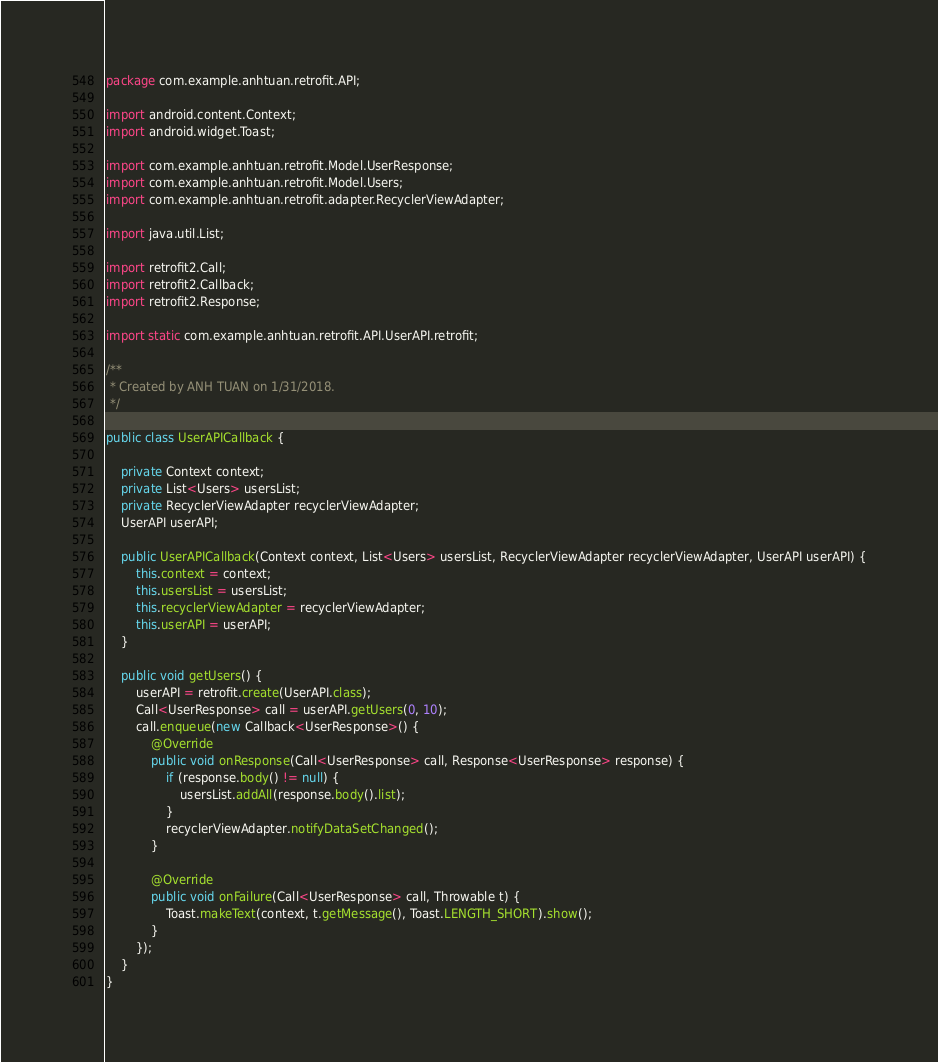<code> <loc_0><loc_0><loc_500><loc_500><_Java_>package com.example.anhtuan.retrofit.API;

import android.content.Context;
import android.widget.Toast;

import com.example.anhtuan.retrofit.Model.UserResponse;
import com.example.anhtuan.retrofit.Model.Users;
import com.example.anhtuan.retrofit.adapter.RecyclerViewAdapter;

import java.util.List;

import retrofit2.Call;
import retrofit2.Callback;
import retrofit2.Response;

import static com.example.anhtuan.retrofit.API.UserAPI.retrofit;

/**
 * Created by ANH TUAN on 1/31/2018.
 */

public class UserAPICallback {

    private Context context;
    private List<Users> usersList;
    private RecyclerViewAdapter recyclerViewAdapter;
    UserAPI userAPI;

    public UserAPICallback(Context context, List<Users> usersList, RecyclerViewAdapter recyclerViewAdapter, UserAPI userAPI) {
        this.context = context;
        this.usersList = usersList;
        this.recyclerViewAdapter = recyclerViewAdapter;
        this.userAPI = userAPI;
    }

    public void getUsers() {
        userAPI = retrofit.create(UserAPI.class);
        Call<UserResponse> call = userAPI.getUsers(0, 10);
        call.enqueue(new Callback<UserResponse>() {
            @Override
            public void onResponse(Call<UserResponse> call, Response<UserResponse> response) {
                if (response.body() != null) {
                    usersList.addAll(response.body().list);
                }
                recyclerViewAdapter.notifyDataSetChanged();
            }

            @Override
            public void onFailure(Call<UserResponse> call, Throwable t) {
                Toast.makeText(context, t.getMessage(), Toast.LENGTH_SHORT).show();
            }
        });
    }
}
</code> 